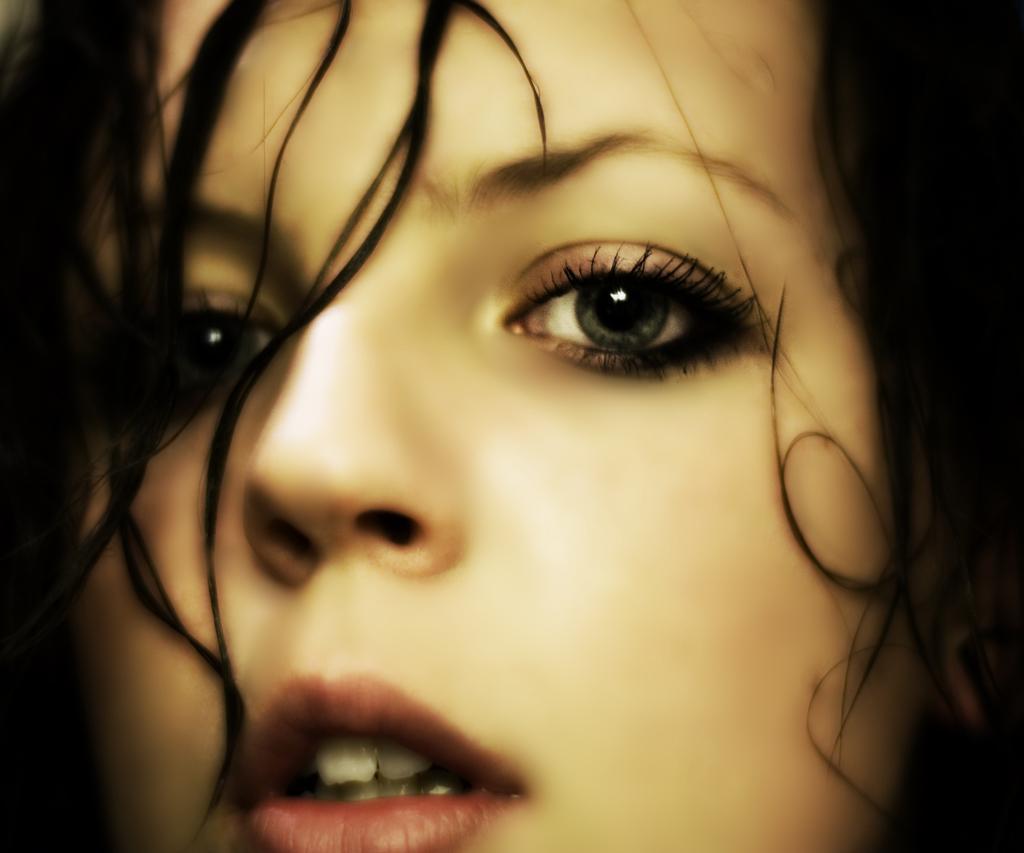In one or two sentences, can you explain what this image depicts? In this picture we can see a woman's face. 